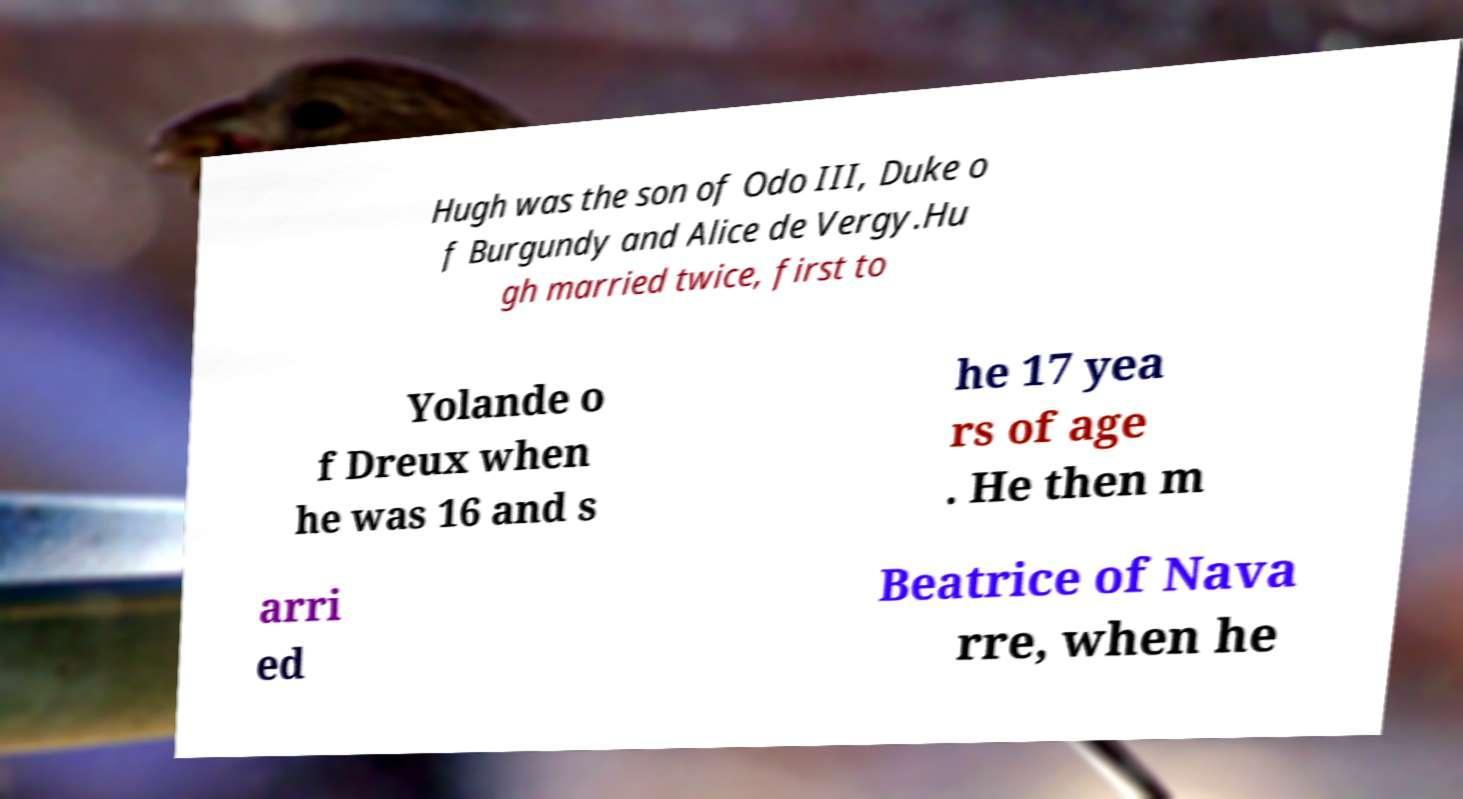Can you read and provide the text displayed in the image?This photo seems to have some interesting text. Can you extract and type it out for me? Hugh was the son of Odo III, Duke o f Burgundy and Alice de Vergy.Hu gh married twice, first to Yolande o f Dreux when he was 16 and s he 17 yea rs of age . He then m arri ed Beatrice of Nava rre, when he 